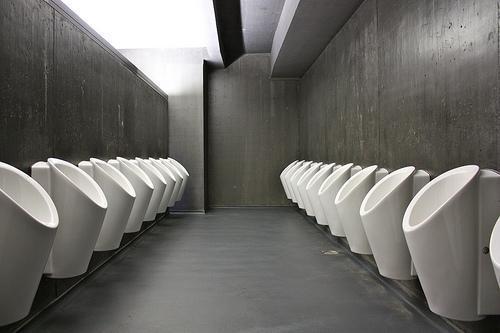How many walls of the room have urinals on them?
Give a very brief answer. 2. 